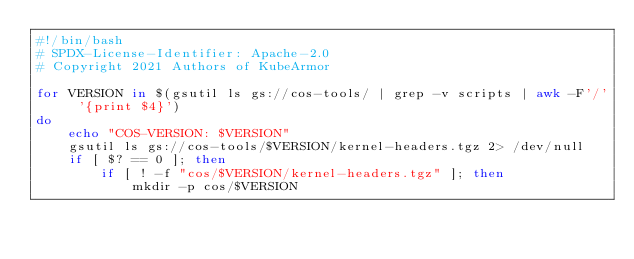<code> <loc_0><loc_0><loc_500><loc_500><_Bash_>#!/bin/bash
# SPDX-License-Identifier: Apache-2.0
# Copyright 2021 Authors of KubeArmor

for VERSION in $(gsutil ls gs://cos-tools/ | grep -v scripts | awk -F'/' '{print $4}')
do
	echo "COS-VERSION: $VERSION"
	gsutil ls gs://cos-tools/$VERSION/kernel-headers.tgz 2> /dev/null
	if [ $? == 0 ]; then
		if [ ! -f "cos/$VERSION/kernel-headers.tgz" ]; then
			mkdir -p cos/$VERSION</code> 